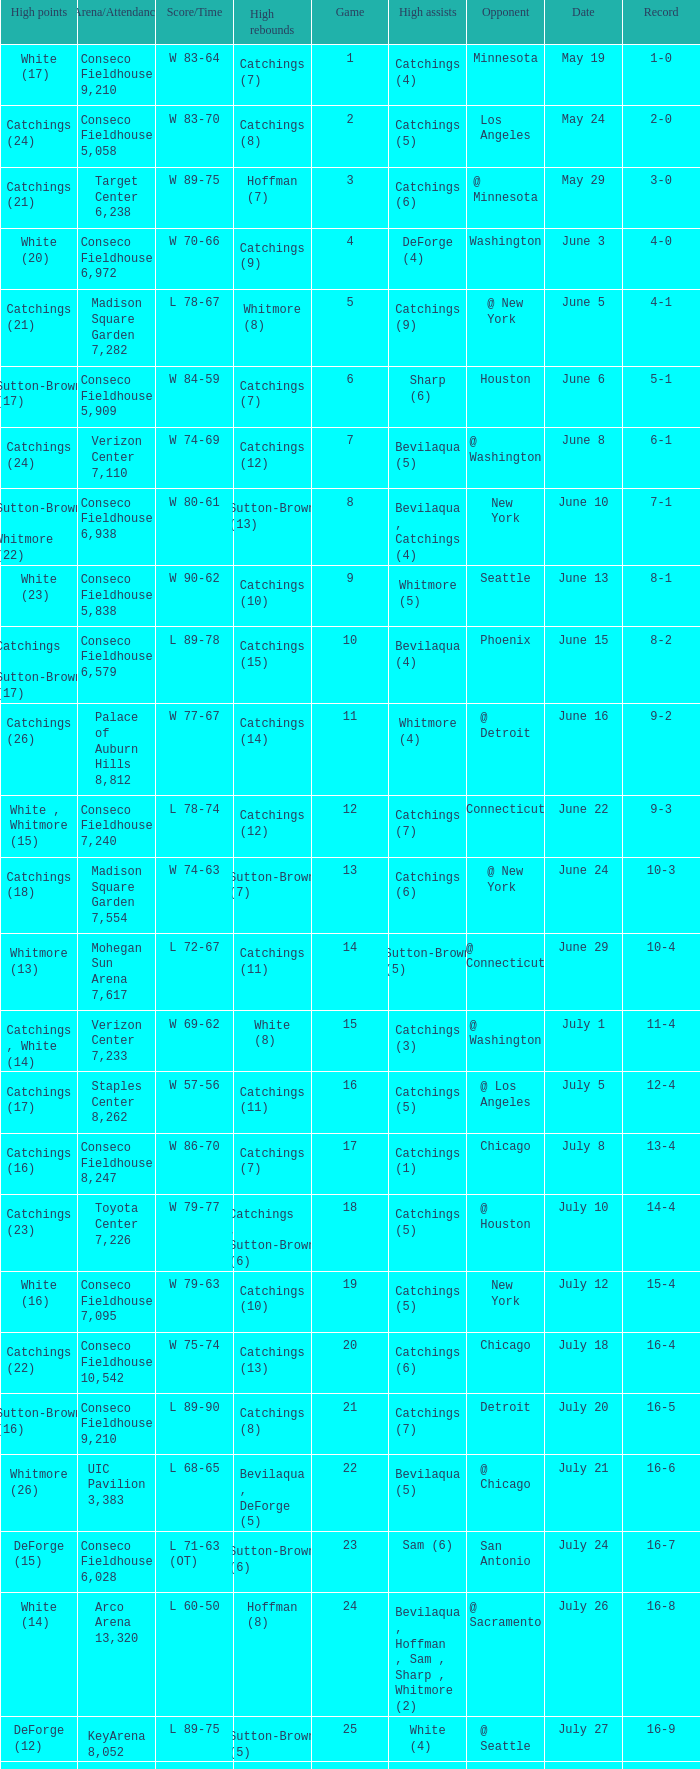Name the date where score time is w 74-63 June 24. 